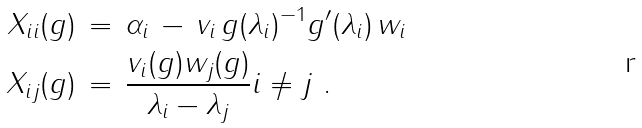<formula> <loc_0><loc_0><loc_500><loc_500>X _ { i i } ( g ) & \, = \, \alpha _ { i } \, - \, v _ { i } \, g ( \lambda _ { i } ) ^ { - 1 } g ^ { \prime } ( \lambda _ { i } ) \, w _ { i } \\ X _ { i j } ( g ) & \, = \, \frac { v _ { i } ( g ) w _ { j } ( g ) } { \lambda _ { i } - \lambda _ { j } } i \neq j \ .</formula> 